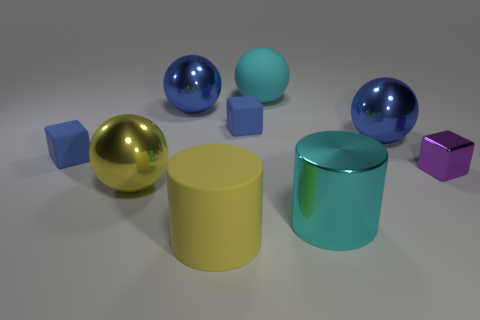There is a yellow object that is to the left of the matte object that is in front of the big shiny ball that is in front of the metallic cube; what is its size?
Your answer should be compact. Large. Does the yellow shiny object have the same shape as the cyan object that is behind the big metal cylinder?
Your response must be concise. Yes. There is a cyan object that is the same material as the yellow cylinder; what is its size?
Provide a short and direct response. Large. Is there anything else that has the same color as the metal cube?
Keep it short and to the point. No. What is the material of the large sphere that is to the right of the big matte object that is on the right side of the big yellow thing to the right of the yellow ball?
Your response must be concise. Metal. How many rubber objects are blue cubes or large green things?
Your answer should be very brief. 2. Does the shiny cube have the same color as the large matte sphere?
Your answer should be very brief. No. Is there anything else that is made of the same material as the purple object?
Your response must be concise. Yes. What number of objects are large objects or tiny blue things that are in front of the cyan sphere?
Give a very brief answer. 8. Is the size of the matte thing on the left side of the yellow metallic object the same as the large cyan matte sphere?
Ensure brevity in your answer.  No. 